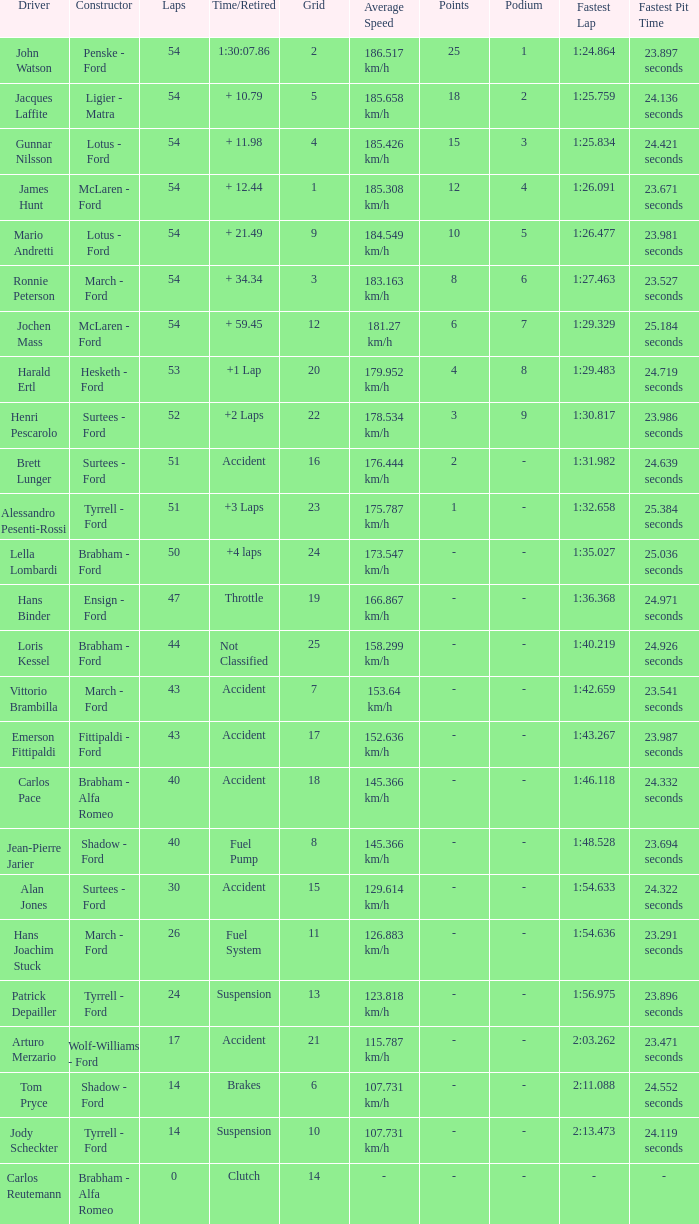How many laps did Emerson Fittipaldi do on a grid larger than 14, and when was the Time/Retired of accident? 1.0. 